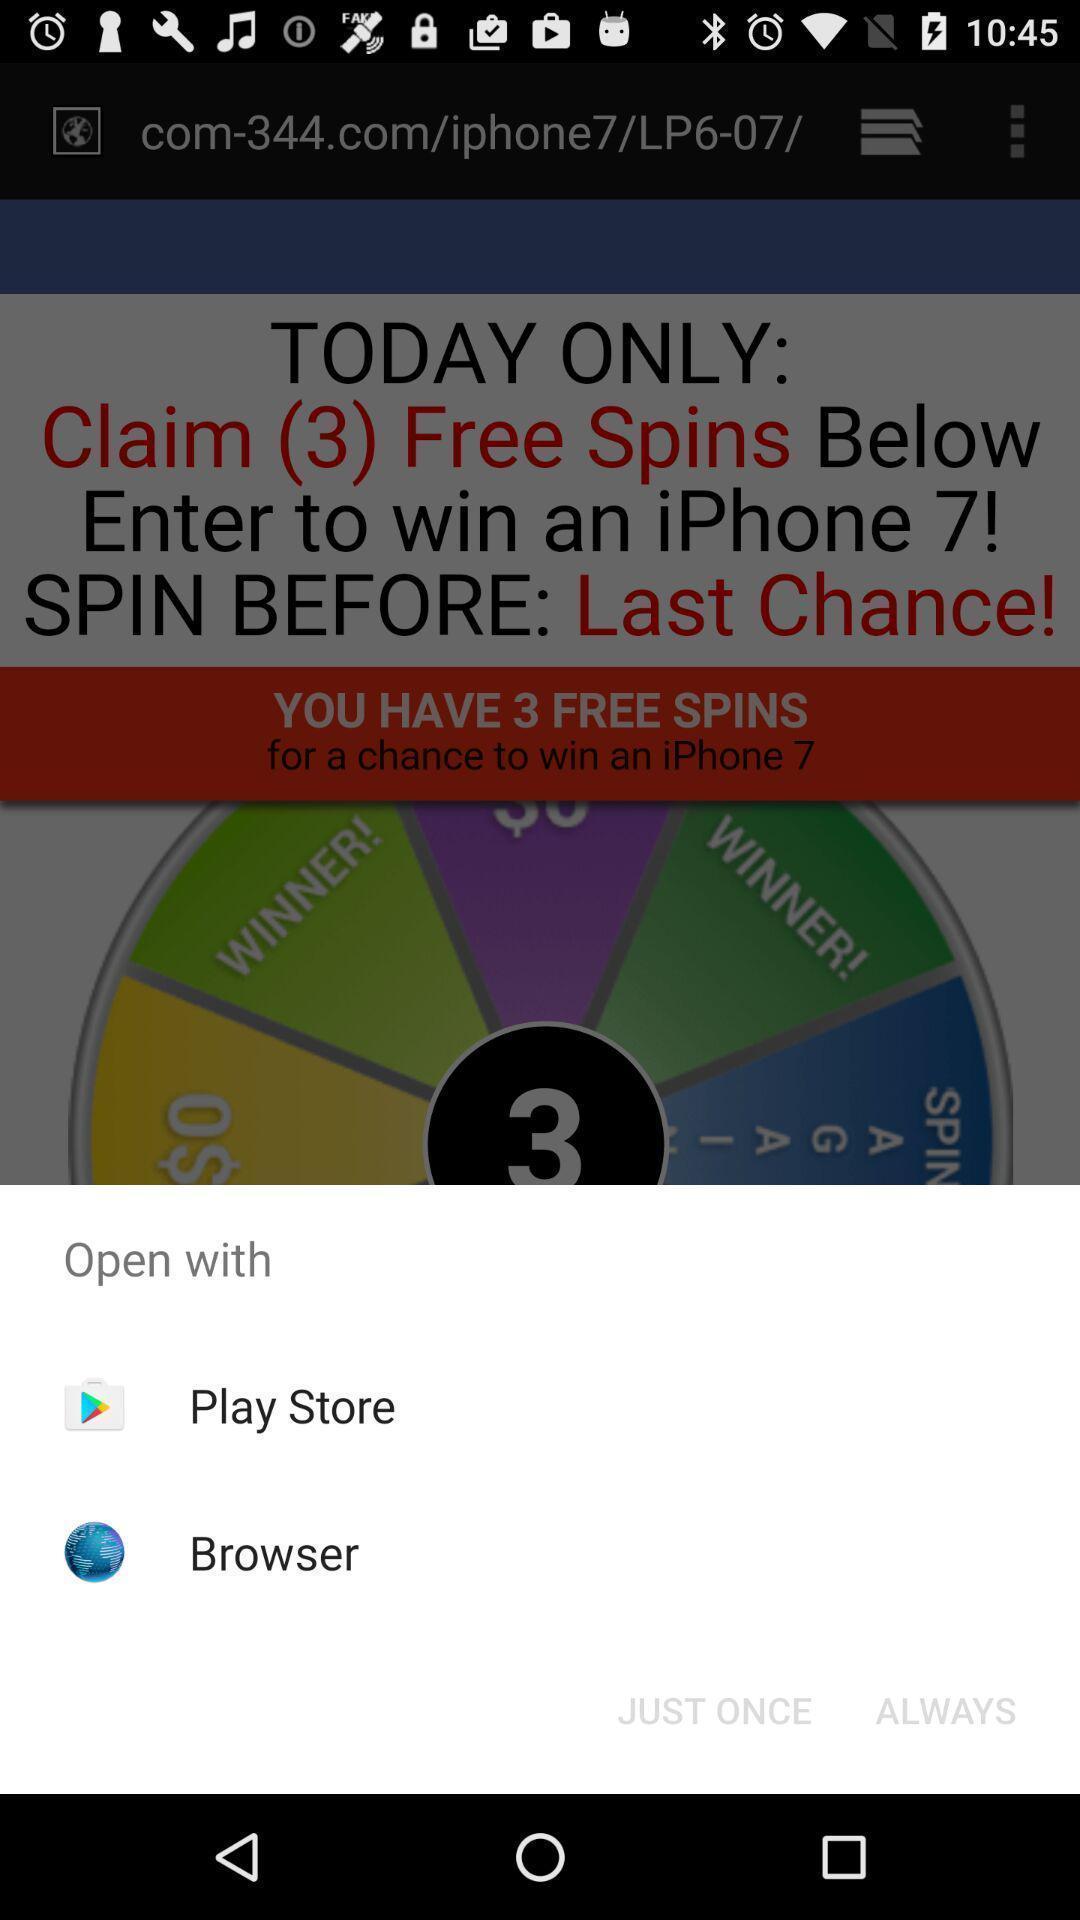Describe the key features of this screenshot. Pop-up showing different options to open. 